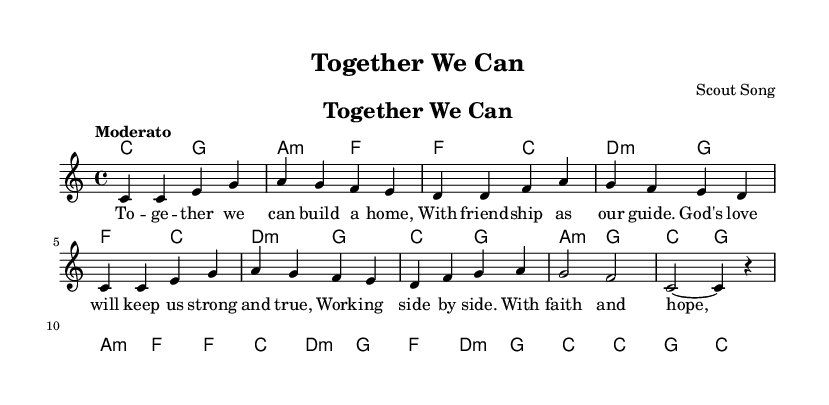What is the key signature of this music? The key signature is indicated at the beginning of the staff and shows C major, which has no sharps or flats.
Answer: C major What is the time signature of this music? The time signature is found next to the key signature at the beginning and is represented as 4/4, meaning there are four beats in each measure.
Answer: 4/4 What is the tempo marking of the piece? The tempo marking is located above the staff and is described as "Moderato," indicating a moderate pace for the music.
Answer: Moderato How many measures are in the melody? By counting the number of distinct sets of notes divided by vertical lines (bar lines), we find there are 16 measures in the melody.
Answer: 16 What is the main theme of the lyrics? The lyrics highlight teamwork and the importance of friendship in building and growing together under God’s guidance, emphasizing support and positive values.
Answer: Teamwork and friendship What chords are used in the first measure? The first measure shows the chord C, which is noted in the chord names section, corresponding to the melody being played in the same measure.
Answer: C How does the phrase structure of the lyrics enhance the message? The lyrics are structured with phrases that align with the melody, creating a rhythmic flow and building a message of unity and faith, each line emphasizing collaboration and support.
Answer: Unity and faith 